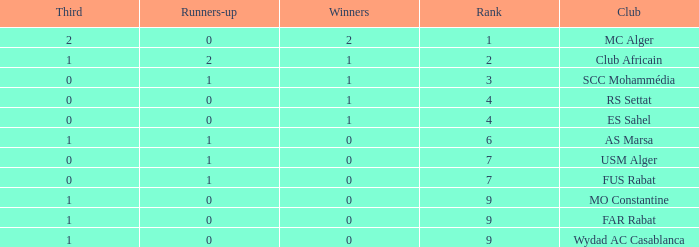Write the full table. {'header': ['Third', 'Runners-up', 'Winners', 'Rank', 'Club'], 'rows': [['2', '0', '2', '1', 'MC Alger'], ['1', '2', '1', '2', 'Club Africain'], ['0', '1', '1', '3', 'SCC Mohammédia'], ['0', '0', '1', '4', 'RS Settat'], ['0', '0', '1', '4', 'ES Sahel'], ['1', '1', '0', '6', 'AS Marsa'], ['0', '1', '0', '7', 'USM Alger'], ['0', '1', '0', '7', 'FUS Rabat'], ['1', '0', '0', '9', 'MO Constantine'], ['1', '0', '0', '9', 'FAR Rabat'], ['1', '0', '0', '9', 'Wydad AC Casablanca']]} Which Third has Runners-up of 0, and Winners of 0, and a Club of far rabat? 1.0. 